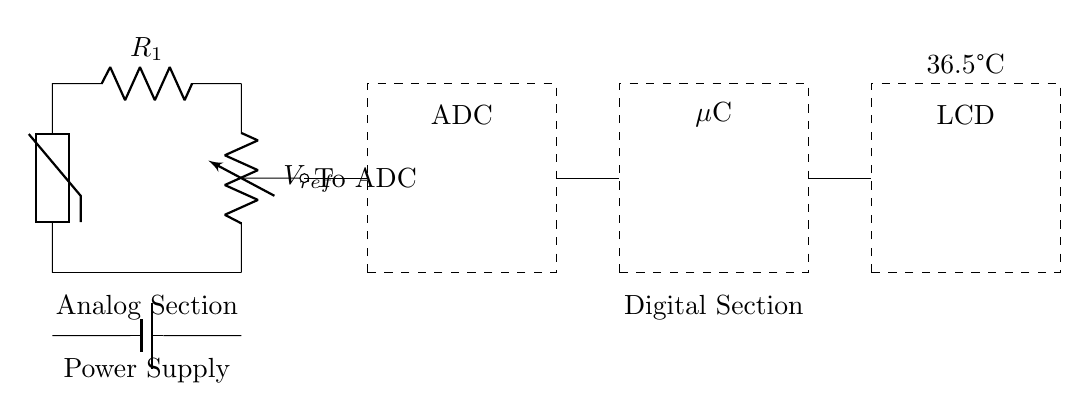What is the component used to measure temperature? The component used to measure temperature in the circuit is a thermistor, which changes resistance based on temperature.
Answer: thermistor What is the reference voltage labeled in the circuit? The reference voltage in the circuit is labeled as V_ref, connecting to the resistor R1 and the thermistor.
Answer: V_ref What type of circuit is this? This is a hybrid circuit that combines an analog section for temperature sensing and a digital section for processing the signal.
Answer: hybrid Which component is responsible for the analog-to-digital conversion? The component responsible for the analog-to-digital conversion is the ADC, which takes the analog signal from the thermistor and converts it into a digital signal for further processing.
Answer: ADC What does the LCD display show? The LCD displays the body temperature reading, which in the diagram is indicated as 36.5 degrees Celsius.
Answer: 36.5°C How is the power supply connected in this circuit? The power supply is connected as a battery at the bottom of the circuit, providing voltage to the analog and digital sections.
Answer: battery 